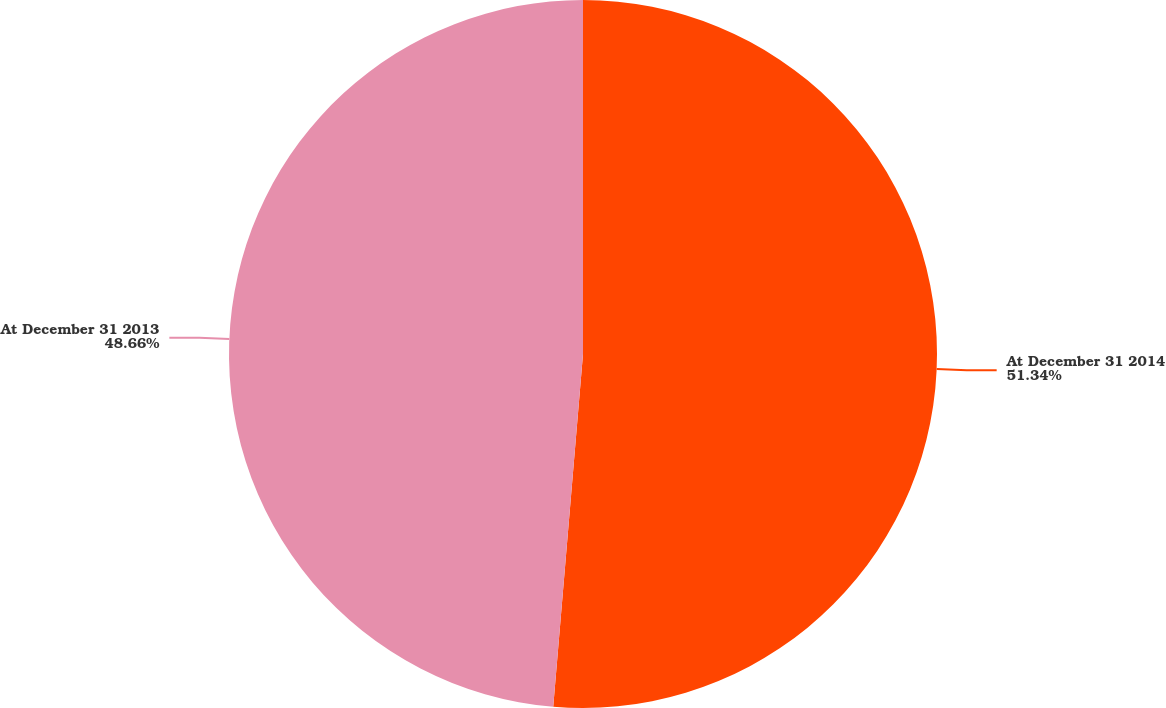<chart> <loc_0><loc_0><loc_500><loc_500><pie_chart><fcel>At December 31 2014<fcel>At December 31 2013<nl><fcel>51.34%<fcel>48.66%<nl></chart> 